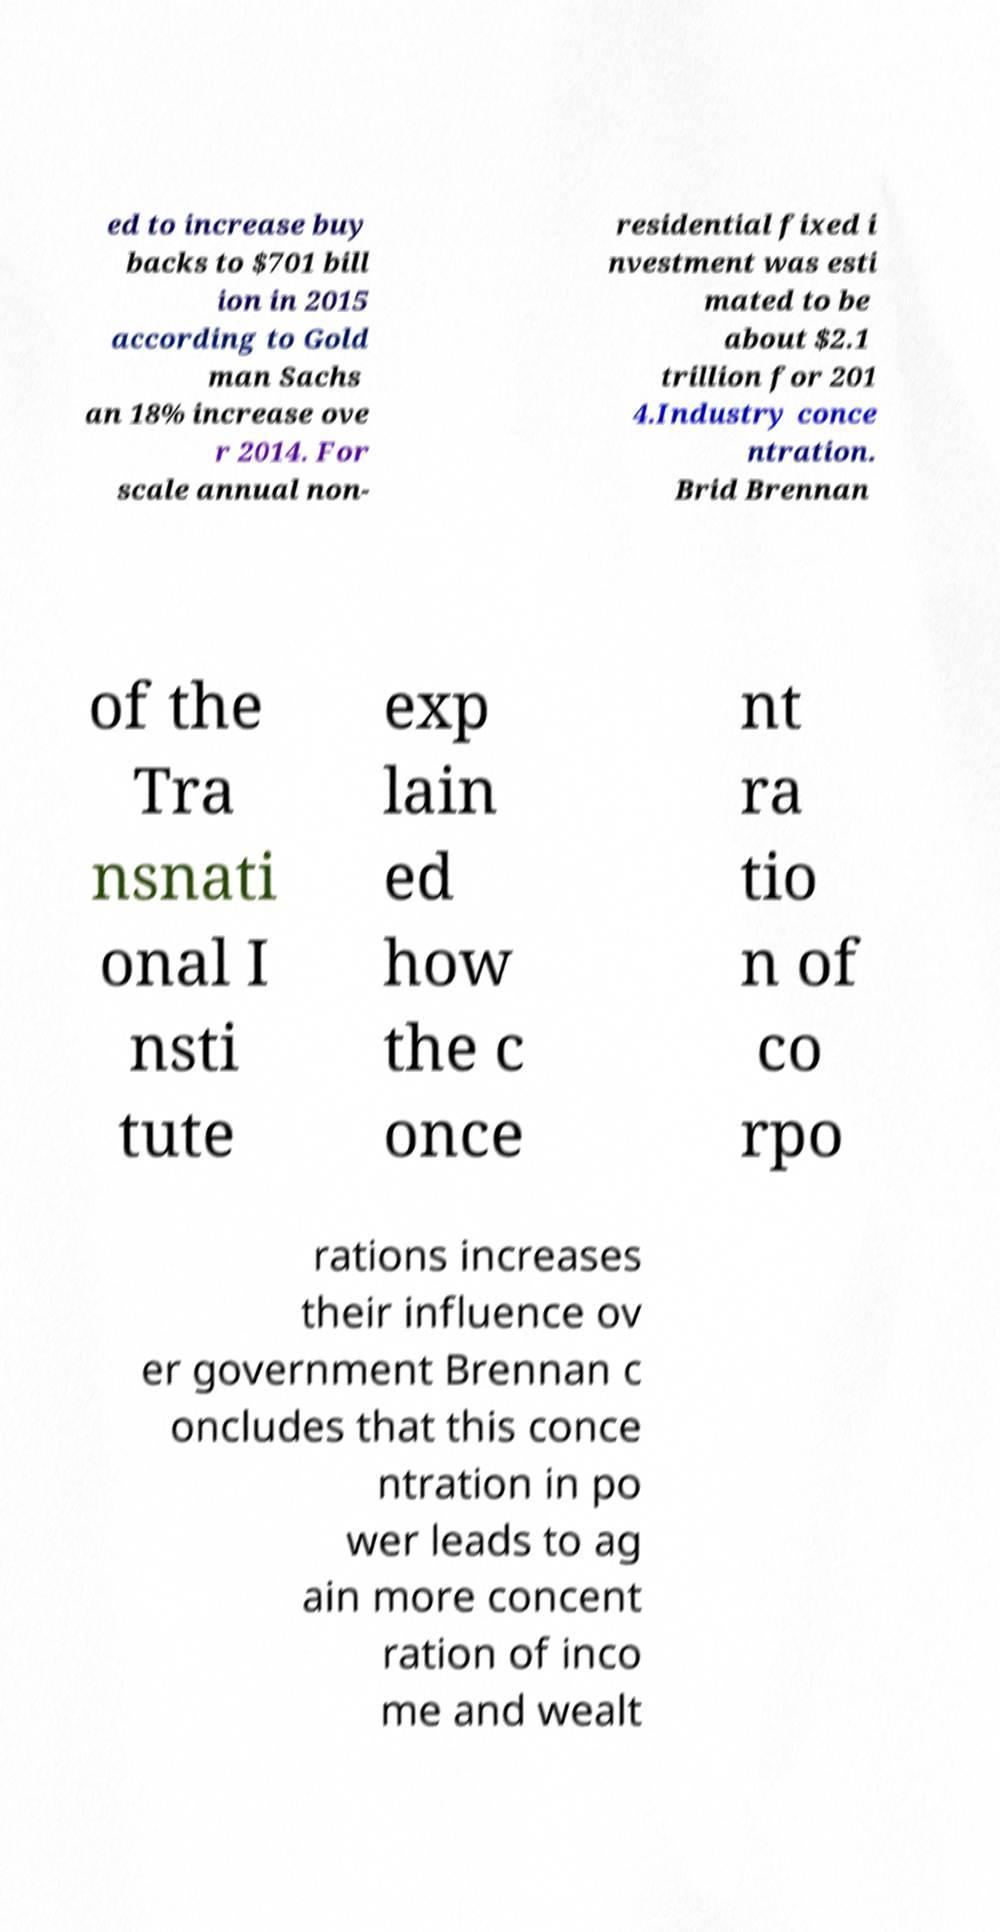Can you accurately transcribe the text from the provided image for me? ed to increase buy backs to $701 bill ion in 2015 according to Gold man Sachs an 18% increase ove r 2014. For scale annual non- residential fixed i nvestment was esti mated to be about $2.1 trillion for 201 4.Industry conce ntration. Brid Brennan of the Tra nsnati onal I nsti tute exp lain ed how the c once nt ra tio n of co rpo rations increases their influence ov er government Brennan c oncludes that this conce ntration in po wer leads to ag ain more concent ration of inco me and wealt 